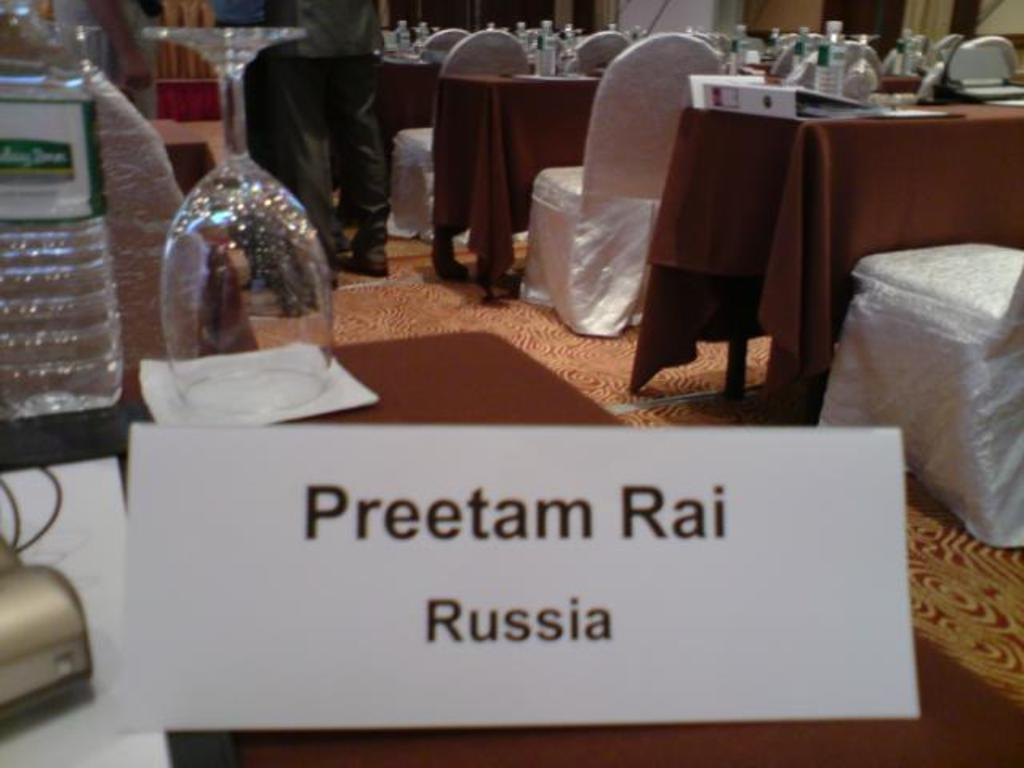What type of furniture is present in the image? There are tables and chairs in the image. What objects can be seen on the table? There are bottles, a file, cards, and glasses on the table. What is the person in the image doing? The person is standing beside the table. What type of pail is visible on the table in the image? There is no pail present on the table in the image. What shape is the bomb on the table in the image? There is no bomb present on the table in the image. 